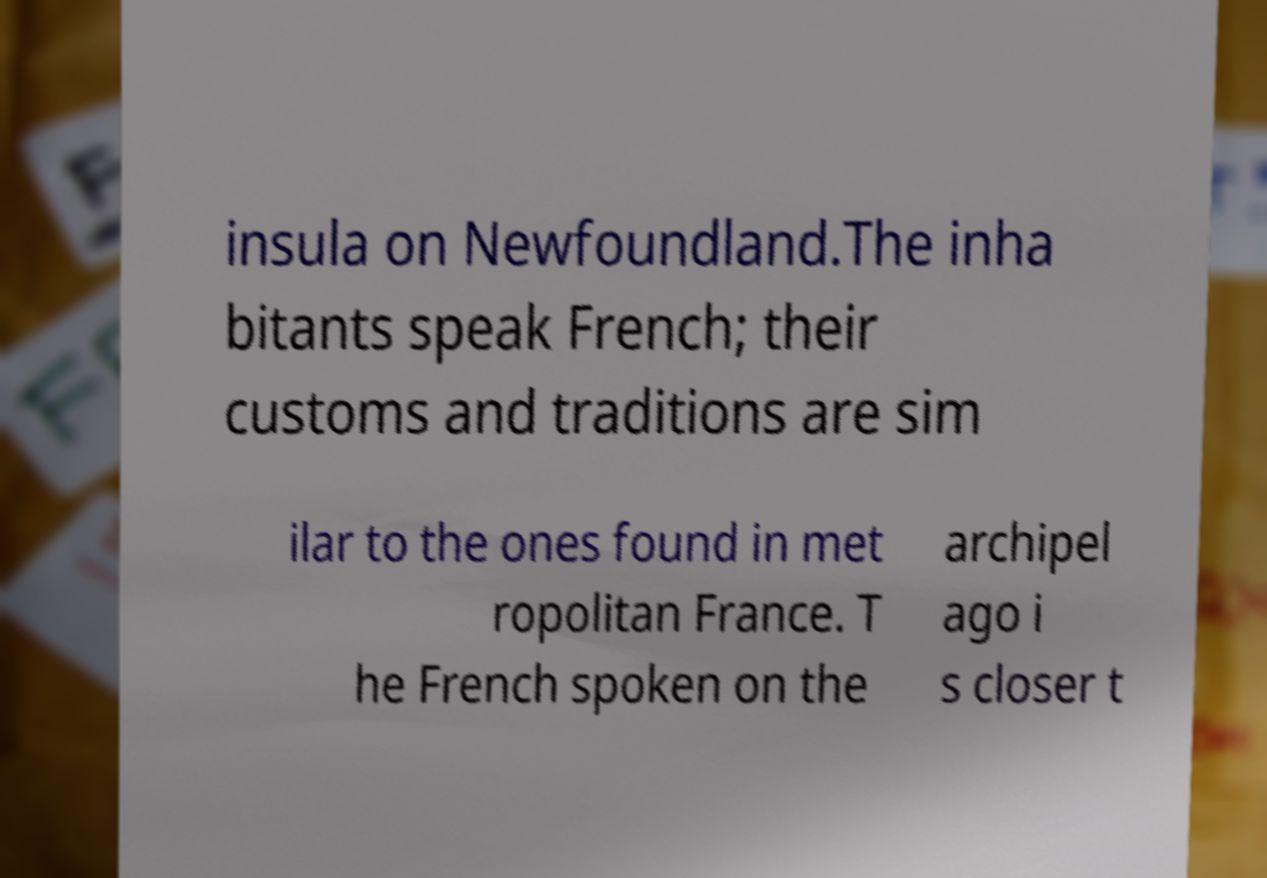For documentation purposes, I need the text within this image transcribed. Could you provide that? insula on Newfoundland.The inha bitants speak French; their customs and traditions are sim ilar to the ones found in met ropolitan France. T he French spoken on the archipel ago i s closer t 